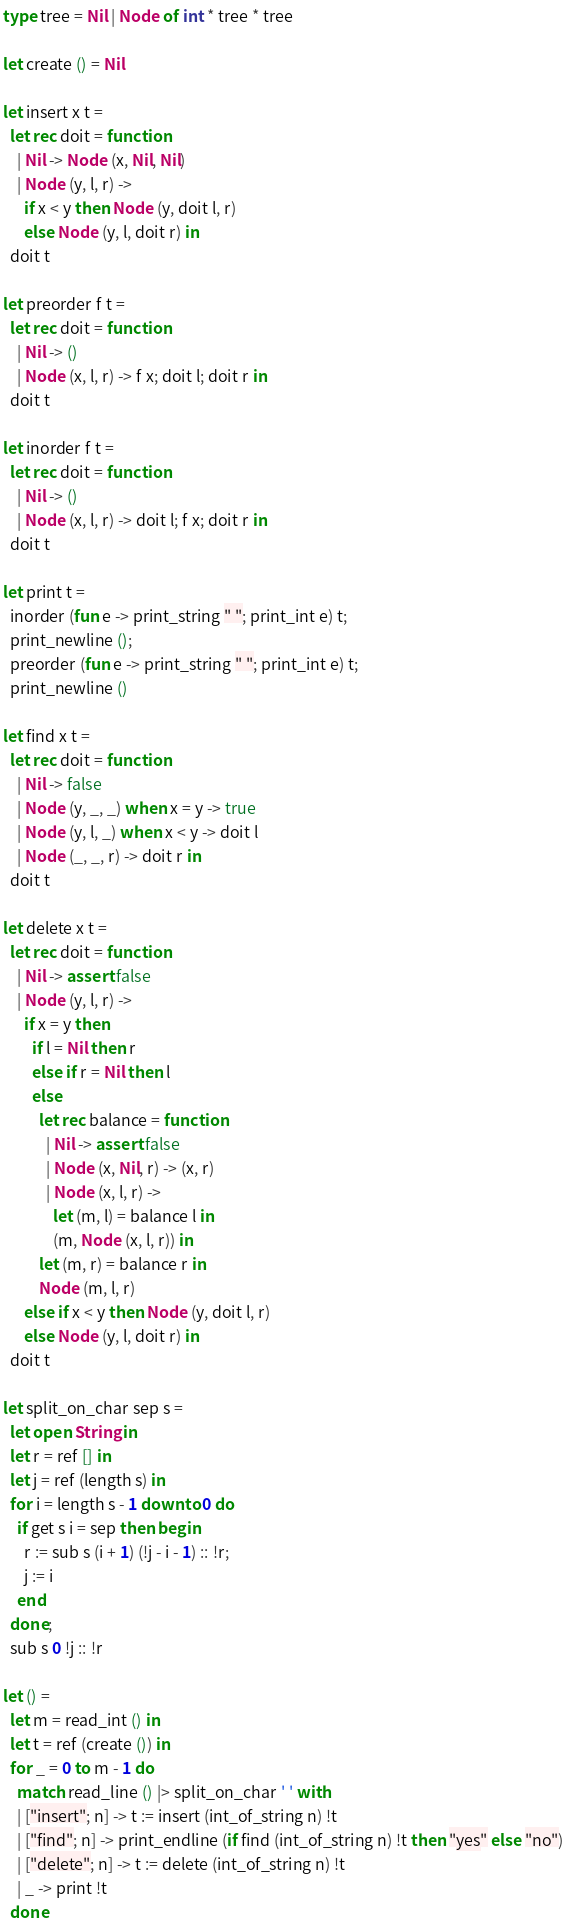Convert code to text. <code><loc_0><loc_0><loc_500><loc_500><_OCaml_>type tree = Nil | Node of int * tree * tree

let create () = Nil

let insert x t =
  let rec doit = function
    | Nil -> Node (x, Nil, Nil)
    | Node (y, l, r) ->
      if x < y then Node (y, doit l, r)
      else Node (y, l, doit r) in
  doit t

let preorder f t =
  let rec doit = function
    | Nil -> ()
    | Node (x, l, r) -> f x; doit l; doit r in
  doit t

let inorder f t =
  let rec doit = function
    | Nil -> ()
    | Node (x, l, r) -> doit l; f x; doit r in
  doit t

let print t =
  inorder (fun e -> print_string " "; print_int e) t;
  print_newline ();
  preorder (fun e -> print_string " "; print_int e) t;
  print_newline ()

let find x t =
  let rec doit = function
    | Nil -> false
    | Node (y, _, _) when x = y -> true
    | Node (y, l, _) when x < y -> doit l
    | Node (_, _, r) -> doit r in
  doit t

let delete x t =
  let rec doit = function
    | Nil -> assert false
    | Node (y, l, r) ->
      if x = y then
        if l = Nil then r
        else if r = Nil then l
        else
          let rec balance = function
            | Nil -> assert false
            | Node (x, Nil, r) -> (x, r)
            | Node (x, l, r) ->
              let (m, l) = balance l in
              (m, Node (x, l, r)) in
          let (m, r) = balance r in
          Node (m, l, r)
      else if x < y then Node (y, doit l, r)
      else Node (y, l, doit r) in
  doit t

let split_on_char sep s =
  let open String in
  let r = ref [] in
  let j = ref (length s) in
  for i = length s - 1 downto 0 do
    if get s i = sep then begin
      r := sub s (i + 1) (!j - i - 1) :: !r;
      j := i
    end
  done;
  sub s 0 !j :: !r

let () =
  let m = read_int () in
  let t = ref (create ()) in
  for _ = 0 to m - 1 do
    match read_line () |> split_on_char ' ' with
    | ["insert"; n] -> t := insert (int_of_string n) !t
    | ["find"; n] -> print_endline (if find (int_of_string n) !t then "yes" else "no")
    | ["delete"; n] -> t := delete (int_of_string n) !t
    | _ -> print !t
  done</code> 